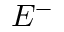<formula> <loc_0><loc_0><loc_500><loc_500>E ^ { - }</formula> 